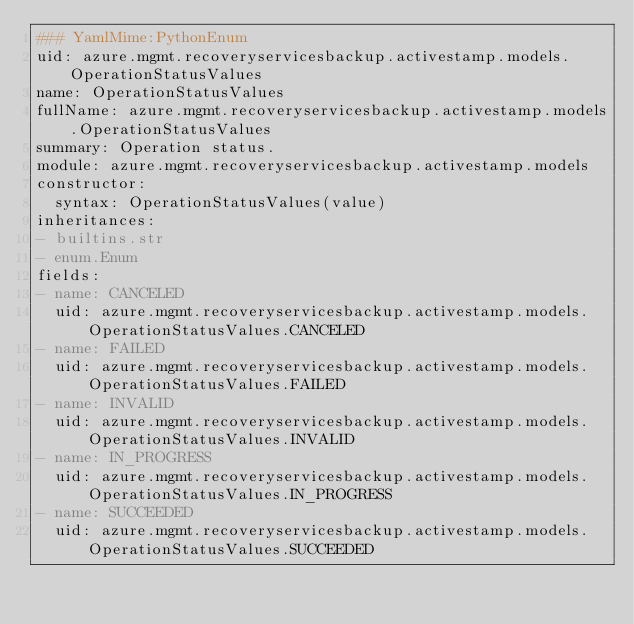<code> <loc_0><loc_0><loc_500><loc_500><_YAML_>### YamlMime:PythonEnum
uid: azure.mgmt.recoveryservicesbackup.activestamp.models.OperationStatusValues
name: OperationStatusValues
fullName: azure.mgmt.recoveryservicesbackup.activestamp.models.OperationStatusValues
summary: Operation status.
module: azure.mgmt.recoveryservicesbackup.activestamp.models
constructor:
  syntax: OperationStatusValues(value)
inheritances:
- builtins.str
- enum.Enum
fields:
- name: CANCELED
  uid: azure.mgmt.recoveryservicesbackup.activestamp.models.OperationStatusValues.CANCELED
- name: FAILED
  uid: azure.mgmt.recoveryservicesbackup.activestamp.models.OperationStatusValues.FAILED
- name: INVALID
  uid: azure.mgmt.recoveryservicesbackup.activestamp.models.OperationStatusValues.INVALID
- name: IN_PROGRESS
  uid: azure.mgmt.recoveryservicesbackup.activestamp.models.OperationStatusValues.IN_PROGRESS
- name: SUCCEEDED
  uid: azure.mgmt.recoveryservicesbackup.activestamp.models.OperationStatusValues.SUCCEEDED
</code> 